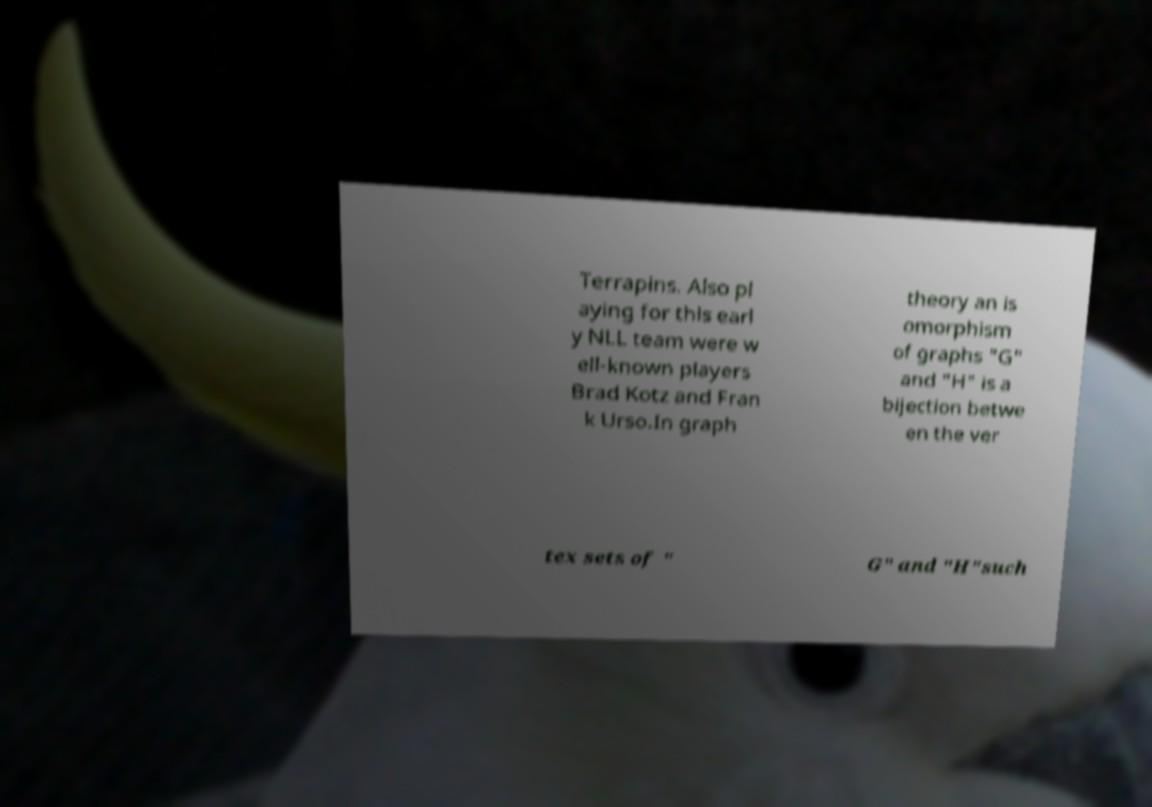Can you accurately transcribe the text from the provided image for me? Terrapins. Also pl aying for this earl y NLL team were w ell-known players Brad Kotz and Fran k Urso.In graph theory an is omorphism of graphs "G" and "H" is a bijection betwe en the ver tex sets of " G" and "H"such 